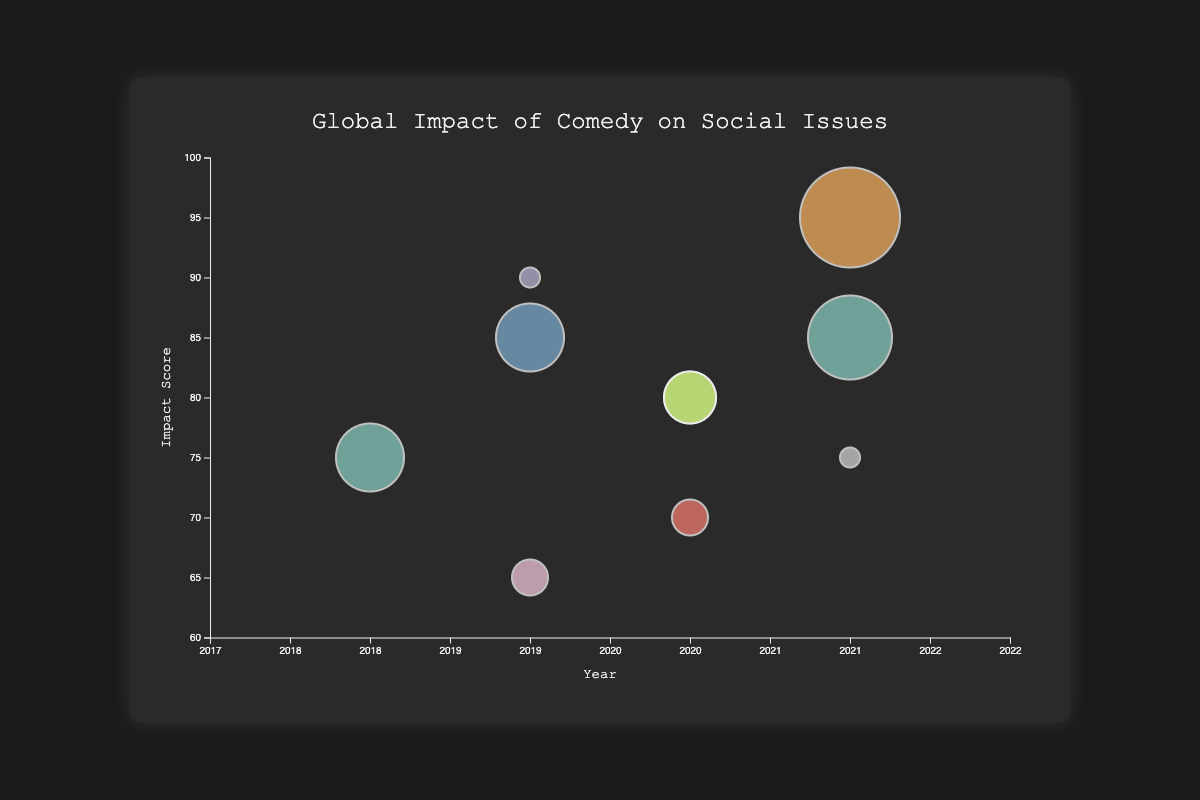What is the title of the figure? The title of the figure is usually prominently displayed at the top of the chart. In this figure, the title is "Global Impact of Comedy on Social Issues."
Answer: Global Impact of Comedy on Social Issues What is depicted on the x-axis? Observing the x-axis, it shows the 'Year' ranging from 2017 to 2022, indicating the years when the data points were collected.
Answer: Year What does the size of each bubble represent? The size of the bubbles is determined by the 'Audience Reach' value, with larger bubbles representing greater audience reach and smaller bubbles representing lesser audience reach.
Answer: Audience Reach Which comedian has the highest Impact Score, and what is it? By locating the highest point on the y-axis, which represents the Impact Score, we can see that Trevor Noah (South Africa) has the highest Impact Score of 95.
Answer: Trevor Noah (95) Compare the Impact Score and Audience Reach of Dave Chappelle and Ellen DeGeneres. Dave Chappelle has an Impact Score of 85 and Audience Reach of 70, whereas Ellen DeGeneres has an Impact Score of 75 and Audience Reach of 65. Therefore, Dave Chappelle has higher scores in both categories compared to Ellen DeGeneres.
Answer: Dave Chappelle has higher scores How many data points are represented in the figure? Counting the number of bubbles visible in the chart, there are 10 data points, each representing a different comedian.
Answer: 10 Which year has the highest cumulative Impact Score? To find this, sum the Impact Scores of all data points by year. The highest cumulative Impact Score occurs in 2021 with Dave Chappelle (85), Trevor Noah (95), and Gad Elmaleh (75), totaling 255.
Answer: 2021 (255) Identify the bubble with both the smallest Impact Score and the lowest Audience Reach. Locate the smallest bubble (lowest Audience Reach) with the lowest vertical position (Impact Score). Ken Shimura (Japan) has the smallest values with an Impact Score of 65 and Audience Reach of 55.
Answer: Ken Shimura Which social issue had the highest Impact Score and which comedian addressed it? The highest Impact Score is 95, addressing Post-Apartheid Society, which is discussed by Trevor Noah (South Africa).
Answer: Post-Apartheid Society (Trevor Noah) What is the relationship between Year and Audience Reach among the comedians? Examine bubbles horizontally and observe the pattern of bubble sizes over years. The size variation shows that Audience Reach does not display a consistent upward or downward trend over the years.
Answer: Inconsistent trend 